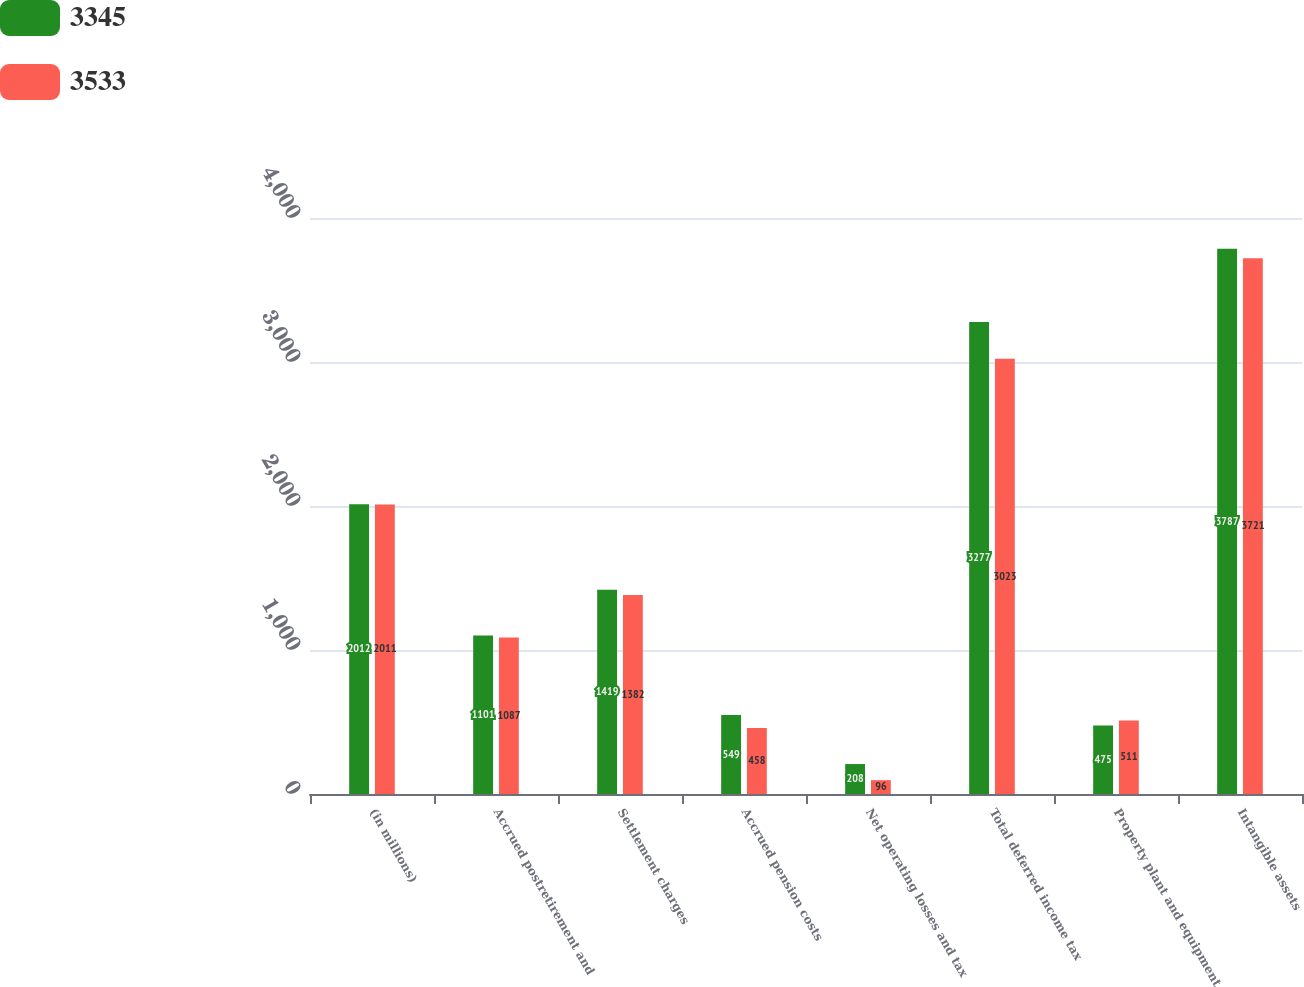Convert chart to OTSL. <chart><loc_0><loc_0><loc_500><loc_500><stacked_bar_chart><ecel><fcel>(in millions)<fcel>Accrued postretirement and<fcel>Settlement charges<fcel>Accrued pension costs<fcel>Net operating losses and tax<fcel>Total deferred income tax<fcel>Property plant and equipment<fcel>Intangible assets<nl><fcel>3345<fcel>2012<fcel>1101<fcel>1419<fcel>549<fcel>208<fcel>3277<fcel>475<fcel>3787<nl><fcel>3533<fcel>2011<fcel>1087<fcel>1382<fcel>458<fcel>96<fcel>3023<fcel>511<fcel>3721<nl></chart> 